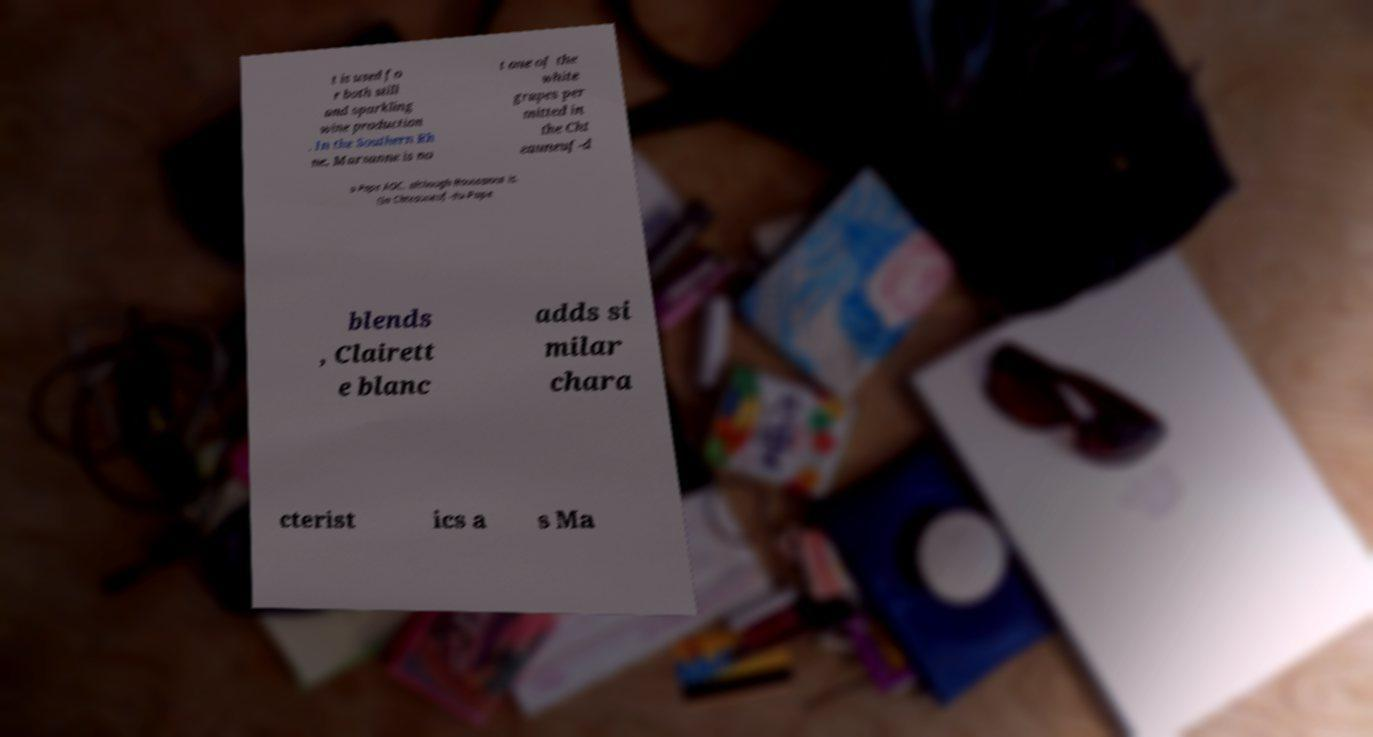Please identify and transcribe the text found in this image. t is used fo r both still and sparkling wine production . In the Southern Rh ne, Marsanne is no t one of the white grapes per mitted in the Cht eauneuf-d u-Pape AOC, although Roussanne is. (In Chteauneuf-du-Pape blends , Clairett e blanc adds si milar chara cterist ics a s Ma 